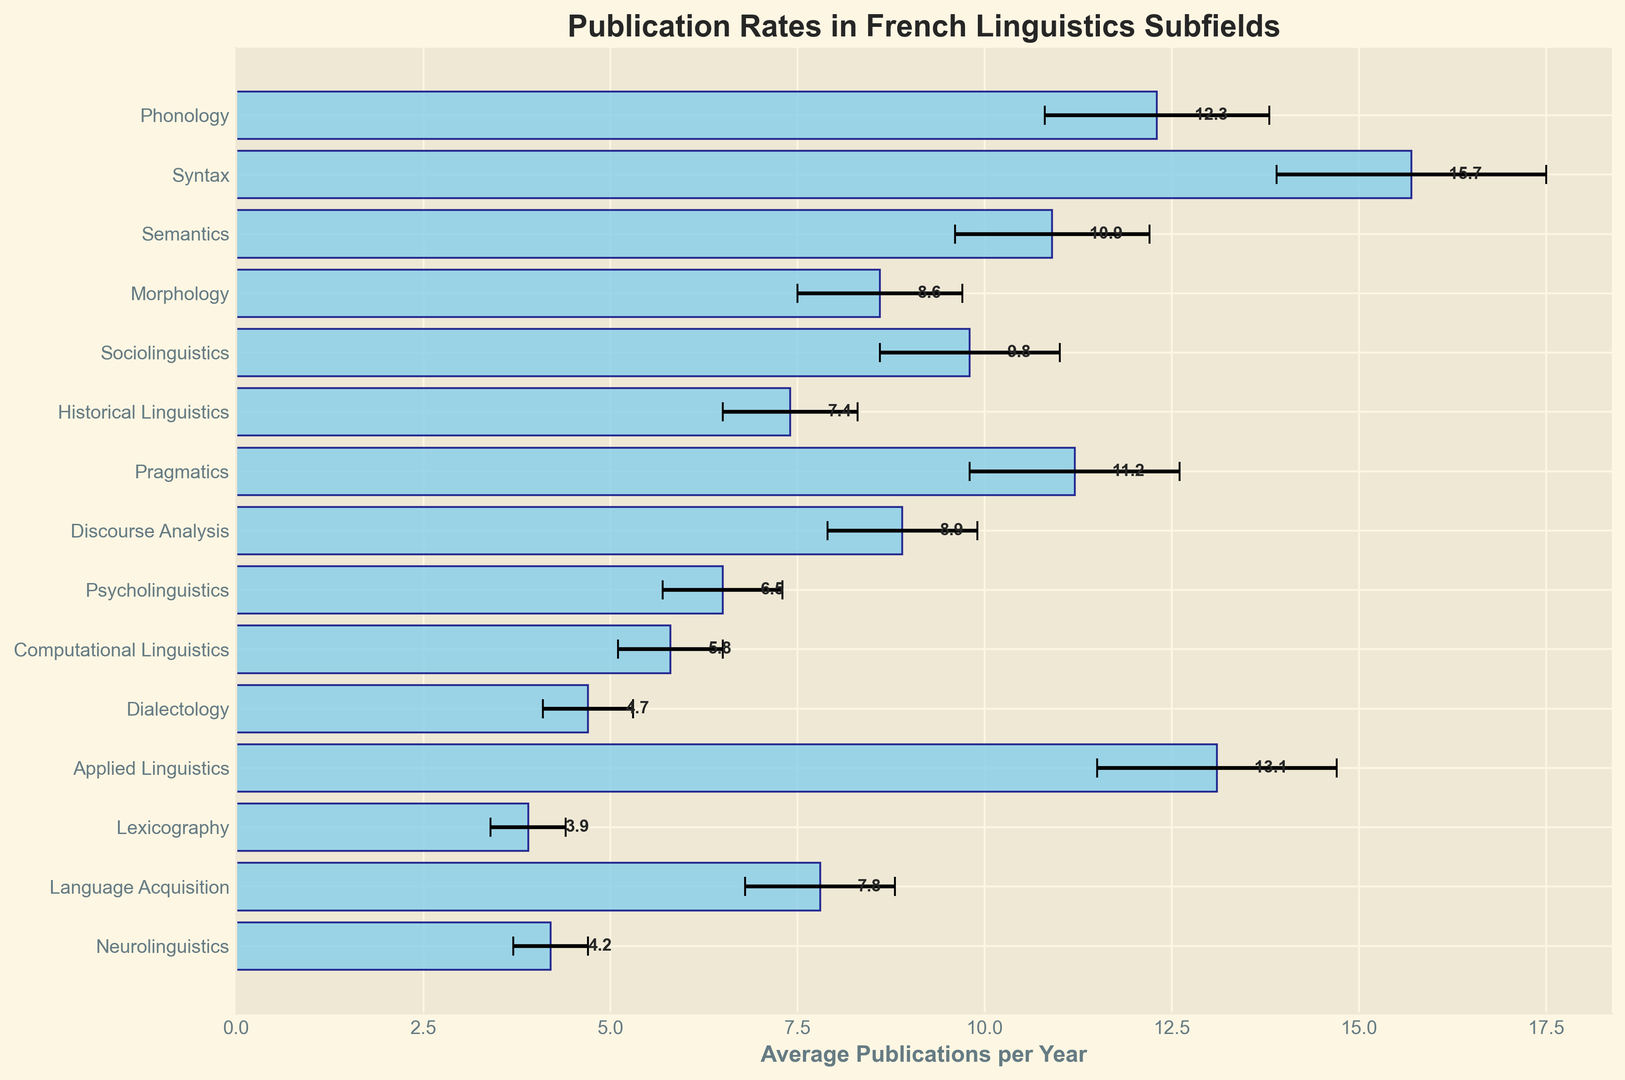Which subfield has the highest average publication rate per year? By looking at the bar chart, the longest bar represents the subfield with the highest average publication rate. This subfield is Syntax.
Answer: Syntax Which subfield has the lowest average publication rate per year? The shortest bar on the chart represents the subfield with the lowest average publication rate. This subfield is Lexicography.
Answer: Lexicography What is the average publication rate of Applied Linguistics, and how does it compare to that of Phonology? The bar for Applied Linguistics shows 13.1, and for Phonology, it shows 12.3. Comparing these, Applied Linguistics has a slightly higher publication rate than Phonology.
Answer: Applied Linguistics: 13.1, Phonology: 12.3 What is the range of the average publication rates across all subfields? The highest publication rate is for Syntax at 15.7, and the lowest is for Lexicography at 3.9. The range is the difference between these values: 15.7 - 3.9 = 11.8.
Answer: 11.8 Which three subfields have the closest average publication rates? By visually inspecting the lengths of the bars, Discourse Analysis (8.9), Morphology (8.6), and Sociolinguistics (9.8) have similar publication rates. These are the closest in numerical values (8.6, 8.9, 9.8).
Answer: Discourse Analysis, Morphology, Sociolinguistics How many subfields have an average publication rate of more than 10? Count the bars that extend beyond the value of 10 on the x-axis. The subfields are Phonology, Syntax, Semantics, Pragmatics, and Applied Linguistics. There are 5 subfields in total with an average publication rate above 10.
Answer: 5 What is the combined average publication rate of Sociolinguistics and Computational Linguistics? Sociolinguistics has an average publication rate of 9.8, and Computational Linguistics has 5.8. The combined rate is 9.8 + 5.8 = 15.6.
Answer: 15.6 Is the publication rate of Psycholinguistics more than double that of Dialectology? The average publication rate of Psycholinguistics is 6.5, and that of Dialectology is 4.7. Double of Dialectology's rate is 4.7 * 2 = 9.4. Since 6.5 is less than 9.4, the publication rate of Psycholinguistics is not more than double that of Dialectology.
Answer: No What is the difference in publication rates between Language Acquisition and Neurolinguistics? The bar representing Language Acquisition shows 7.8, and for Neurolinguistics, it shows 4.2. The difference is 7.8 - 4.2 = 3.6.
Answer: 3.6 